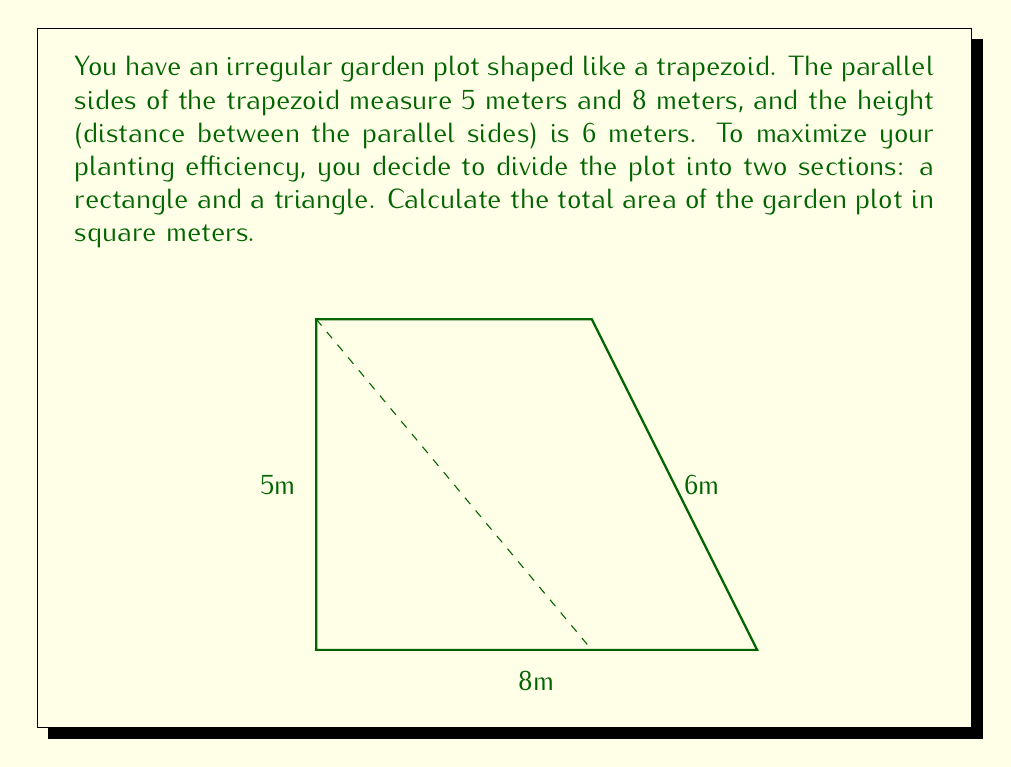Give your solution to this math problem. Let's approach this step-by-step:

1) First, we need to recognize that the total area of the trapezoid can be calculated using the formula:

   $$A_{trapezoid} = \frac{1}{2}(b_1 + b_2)h$$

   Where $b_1$ and $b_2$ are the lengths of the parallel sides, and $h$ is the height.

2) We're given that $b_1 = 5$ m, $b_2 = 8$ m, and $h = 6$ m.

3) Let's substitute these values into the formula:

   $$A_{trapezoid} = \frac{1}{2}(5 + 8) \times 6$$

4) Simplify:
   
   $$A_{trapezoid} = \frac{1}{2}(13) \times 6 = 6.5 \times 6 = 39$$

5) Therefore, the total area of the garden plot is 39 square meters.

Note: While the question mentions dividing the plot into a rectangle and a triangle, this division is not necessary for calculating the total area. The trapezoid formula gives us the total area directly.
Answer: 39 m² 